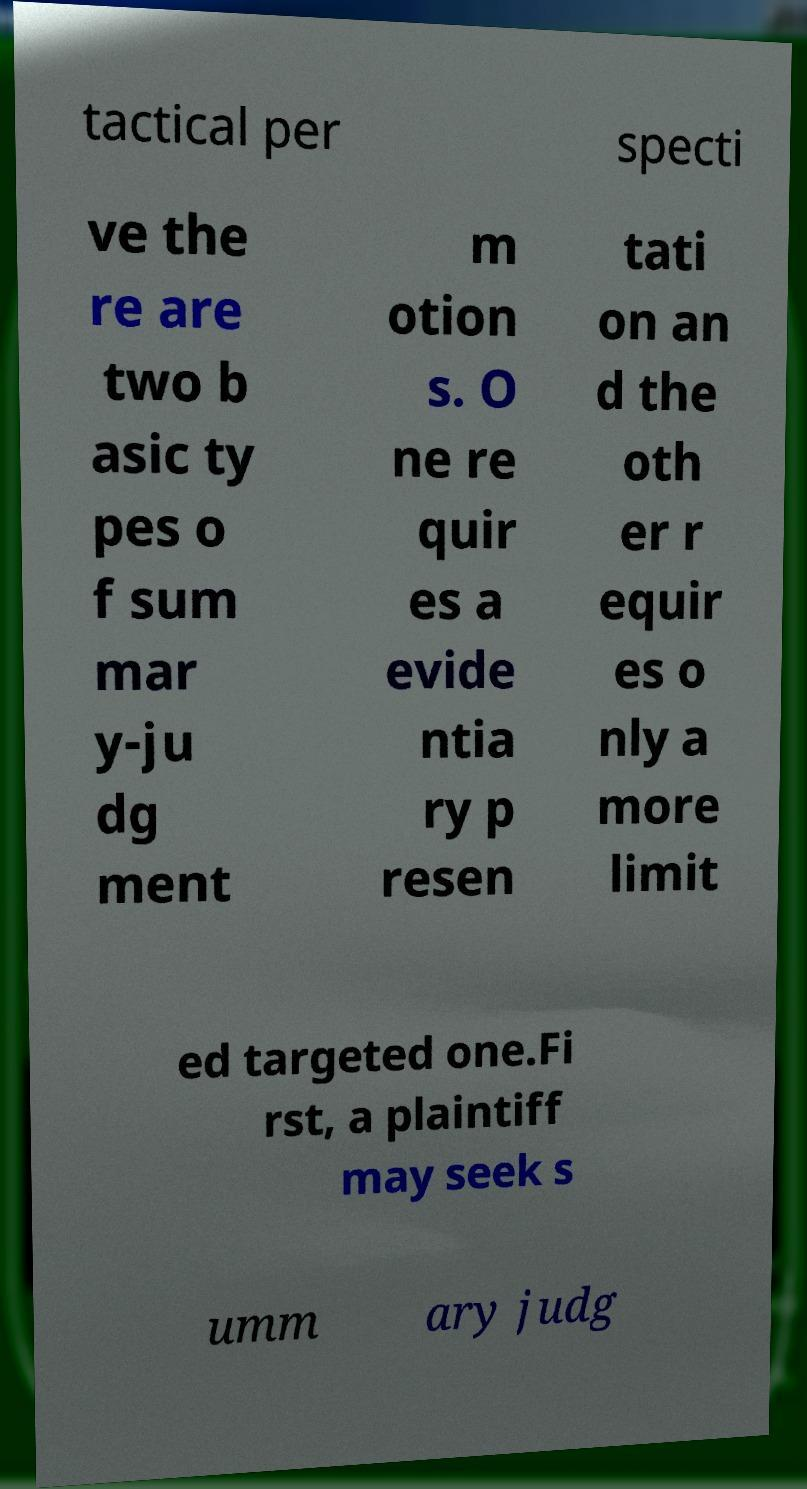Could you extract and type out the text from this image? tactical per specti ve the re are two b asic ty pes o f sum mar y-ju dg ment m otion s. O ne re quir es a evide ntia ry p resen tati on an d the oth er r equir es o nly a more limit ed targeted one.Fi rst, a plaintiff may seek s umm ary judg 